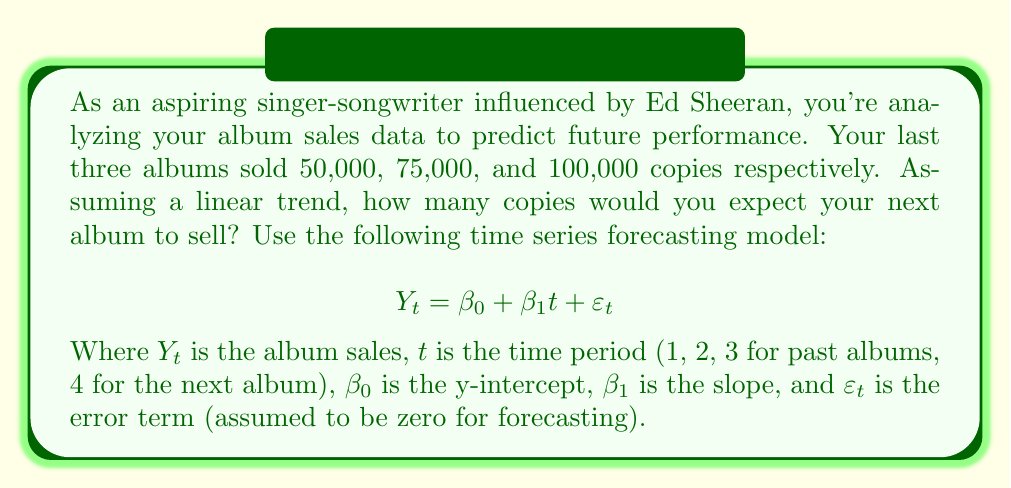Teach me how to tackle this problem. To solve this problem, we need to follow these steps:

1. Calculate the slope ($\beta_1$) using the formula:
   $$\beta_1 = \frac{n\sum{ty} - \sum{t}\sum{y}}{n\sum{t^2} - (\sum{t})^2}$$

2. Calculate the y-intercept ($\beta_0$) using the formula:
   $$\beta_0 = \bar{y} - \beta_1\bar{t}$$

3. Use the forecasting model to predict sales for the 4th album.

Step 1: Calculate $\beta_1$
$n = 3$
$\sum{t} = 1 + 2 + 3 = 6$
$\sum{y} = 50,000 + 75,000 + 100,000 = 225,000$
$\sum{ty} = 1(50,000) + 2(75,000) + 3(100,000) = 500,000$
$\sum{t^2} = 1^2 + 2^2 + 3^2 = 14$

$$\beta_1 = \frac{3(500,000) - 6(225,000)}{3(14) - 6^2} = \frac{1,500,000 - 1,350,000}{42 - 36} = \frac{150,000}{6} = 25,000$$

Step 2: Calculate $\beta_0$
$\bar{t} = \frac{1 + 2 + 3}{3} = 2$
$\bar{y} = \frac{225,000}{3} = 75,000$

$$\beta_0 = 75,000 - 25,000(2) = 25,000$$

Step 3: Forecast sales for the 4th album
$$Y_4 = \beta_0 + \beta_1(4) = 25,000 + 25,000(4) = 125,000$$

Therefore, based on the linear trend, you would expect your next album to sell 125,000 copies.
Answer: 125,000 copies 